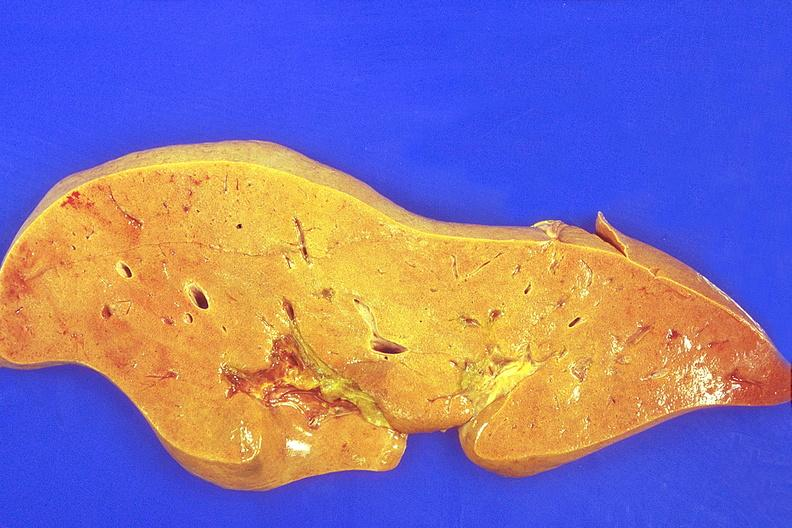does this image show liver, fatty change?
Answer the question using a single word or phrase. Yes 